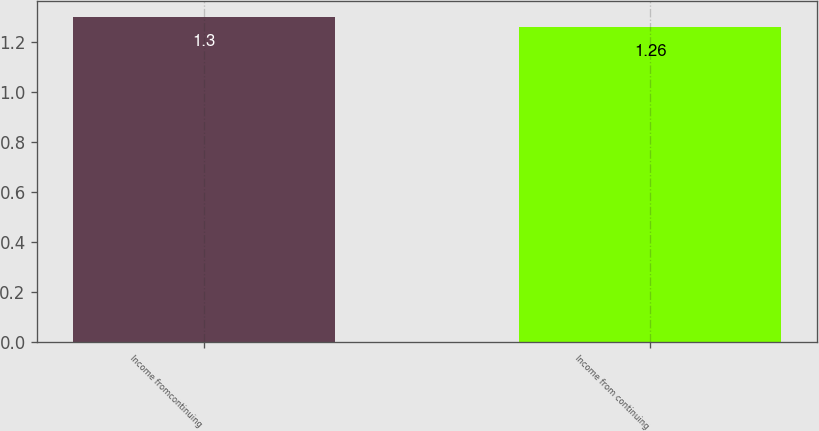Convert chart to OTSL. <chart><loc_0><loc_0><loc_500><loc_500><bar_chart><fcel>Income fromcontinuing<fcel>Income from continuing<nl><fcel>1.3<fcel>1.26<nl></chart> 